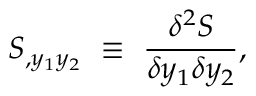<formula> <loc_0><loc_0><loc_500><loc_500>S _ { , y _ { 1 } y _ { 2 } } \equiv { \frac { \delta ^ { 2 } S } { \delta y _ { 1 } \delta y _ { 2 } } } ,</formula> 